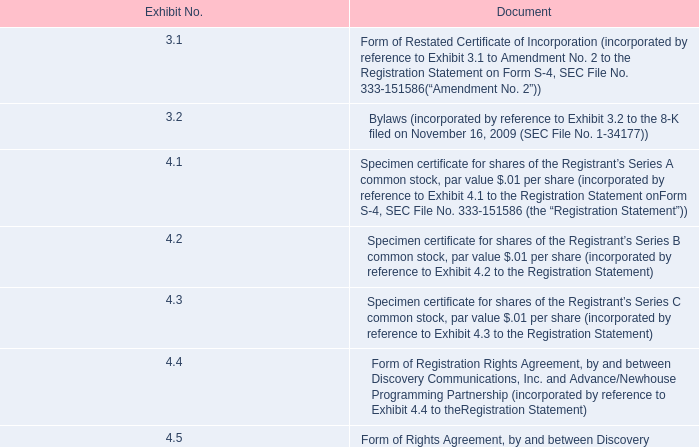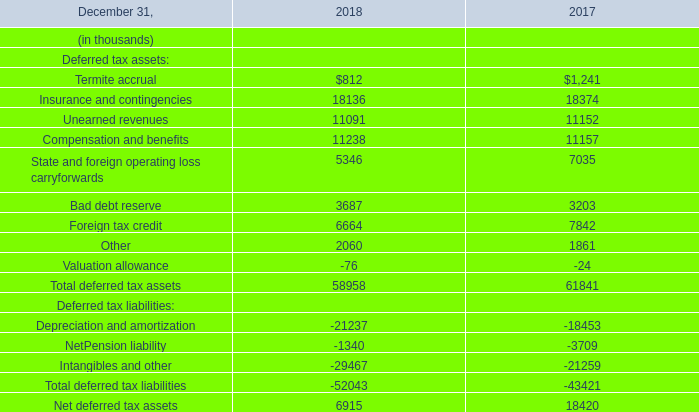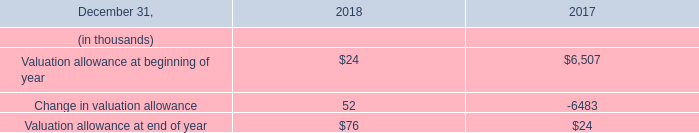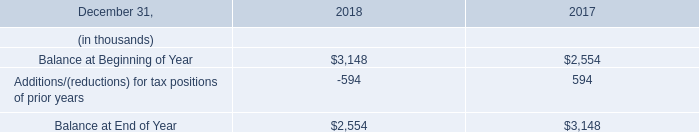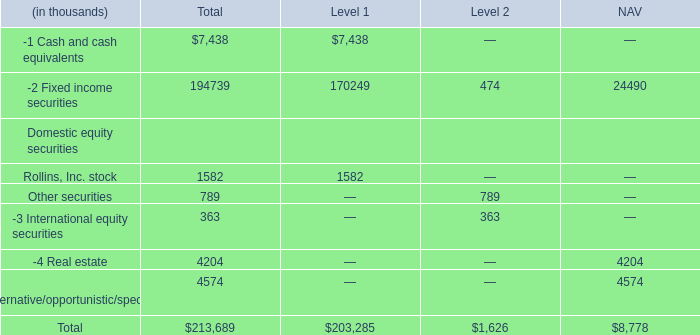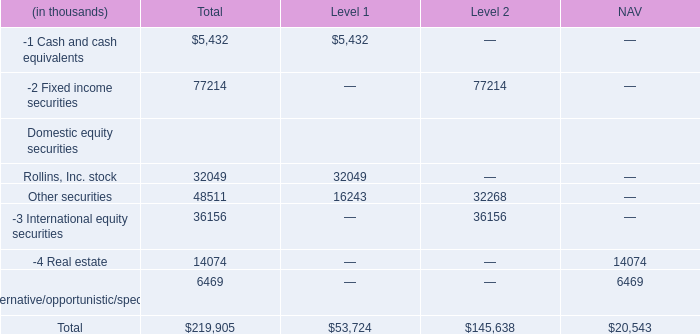what's the total amount of Balance at Beginning of Year of 2018, and Insurance and contingencies of 2018 ? 
Computations: (3148.0 + 18136.0)
Answer: 21284.0. 